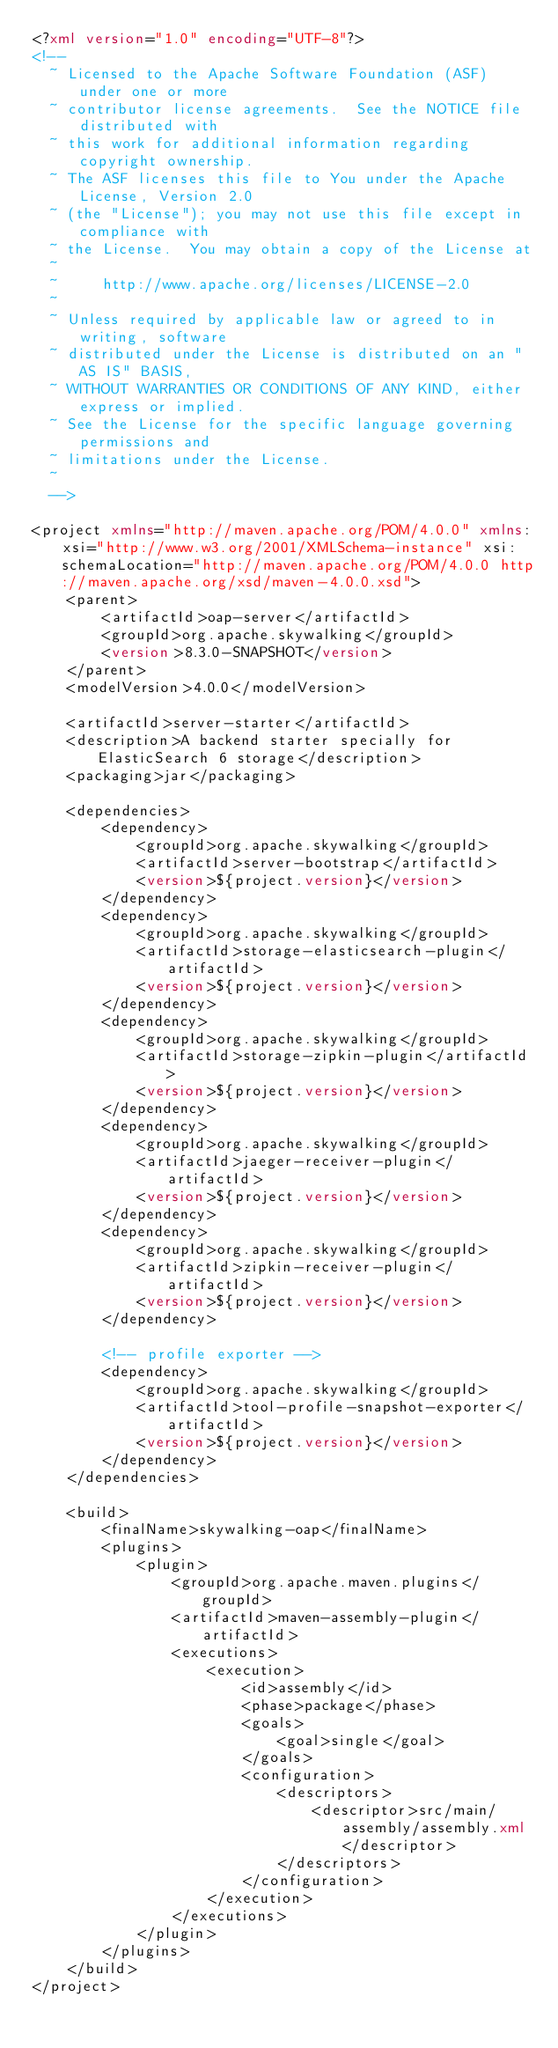<code> <loc_0><loc_0><loc_500><loc_500><_XML_><?xml version="1.0" encoding="UTF-8"?>
<!--
  ~ Licensed to the Apache Software Foundation (ASF) under one or more
  ~ contributor license agreements.  See the NOTICE file distributed with
  ~ this work for additional information regarding copyright ownership.
  ~ The ASF licenses this file to You under the Apache License, Version 2.0
  ~ (the "License"); you may not use this file except in compliance with
  ~ the License.  You may obtain a copy of the License at
  ~
  ~     http://www.apache.org/licenses/LICENSE-2.0
  ~
  ~ Unless required by applicable law or agreed to in writing, software
  ~ distributed under the License is distributed on an "AS IS" BASIS,
  ~ WITHOUT WARRANTIES OR CONDITIONS OF ANY KIND, either express or implied.
  ~ See the License for the specific language governing permissions and
  ~ limitations under the License.
  ~
  -->

<project xmlns="http://maven.apache.org/POM/4.0.0" xmlns:xsi="http://www.w3.org/2001/XMLSchema-instance" xsi:schemaLocation="http://maven.apache.org/POM/4.0.0 http://maven.apache.org/xsd/maven-4.0.0.xsd">
    <parent>
        <artifactId>oap-server</artifactId>
        <groupId>org.apache.skywalking</groupId>
        <version>8.3.0-SNAPSHOT</version>
    </parent>
    <modelVersion>4.0.0</modelVersion>

    <artifactId>server-starter</artifactId>
    <description>A backend starter specially for ElasticSearch 6 storage</description>
    <packaging>jar</packaging>

    <dependencies>
        <dependency>
            <groupId>org.apache.skywalking</groupId>
            <artifactId>server-bootstrap</artifactId>
            <version>${project.version}</version>
        </dependency>
        <dependency>
            <groupId>org.apache.skywalking</groupId>
            <artifactId>storage-elasticsearch-plugin</artifactId>
            <version>${project.version}</version>
        </dependency>
        <dependency>
            <groupId>org.apache.skywalking</groupId>
            <artifactId>storage-zipkin-plugin</artifactId>
            <version>${project.version}</version>
        </dependency>
        <dependency>
            <groupId>org.apache.skywalking</groupId>
            <artifactId>jaeger-receiver-plugin</artifactId>
            <version>${project.version}</version>
        </dependency>
        <dependency>
            <groupId>org.apache.skywalking</groupId>
            <artifactId>zipkin-receiver-plugin</artifactId>
            <version>${project.version}</version>
        </dependency>

        <!-- profile exporter -->
        <dependency>
            <groupId>org.apache.skywalking</groupId>
            <artifactId>tool-profile-snapshot-exporter</artifactId>
            <version>${project.version}</version>
        </dependency>
    </dependencies>

    <build>
        <finalName>skywalking-oap</finalName>
        <plugins>
            <plugin>
                <groupId>org.apache.maven.plugins</groupId>
                <artifactId>maven-assembly-plugin</artifactId>
                <executions>
                    <execution>
                        <id>assembly</id>
                        <phase>package</phase>
                        <goals>
                            <goal>single</goal>
                        </goals>
                        <configuration>
                            <descriptors>
                                <descriptor>src/main/assembly/assembly.xml</descriptor>
                            </descriptors>
                        </configuration>
                    </execution>
                </executions>
            </plugin>
        </plugins>
    </build>
</project>
</code> 